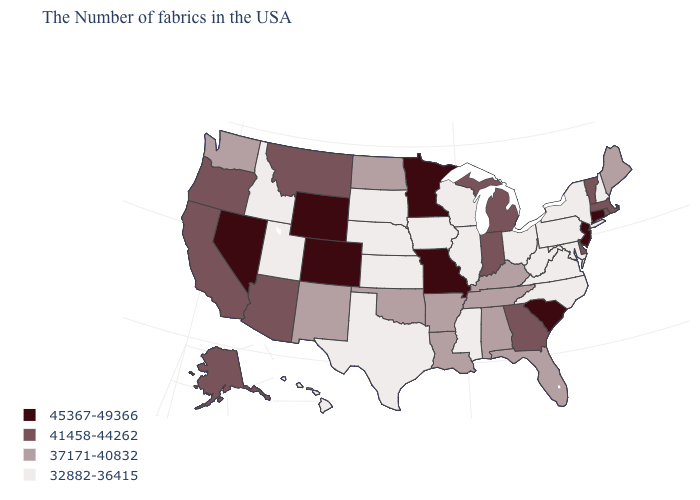Which states have the lowest value in the Northeast?
Write a very short answer. New Hampshire, New York, Pennsylvania. What is the value of Michigan?
Keep it brief. 41458-44262. Name the states that have a value in the range 37171-40832?
Be succinct. Maine, Florida, Kentucky, Alabama, Tennessee, Louisiana, Arkansas, Oklahoma, North Dakota, New Mexico, Washington. Which states hav the highest value in the MidWest?
Keep it brief. Missouri, Minnesota. Does the first symbol in the legend represent the smallest category?
Answer briefly. No. Among the states that border Georgia , does North Carolina have the lowest value?
Be succinct. Yes. Name the states that have a value in the range 37171-40832?
Keep it brief. Maine, Florida, Kentucky, Alabama, Tennessee, Louisiana, Arkansas, Oklahoma, North Dakota, New Mexico, Washington. Does Ohio have the highest value in the USA?
Give a very brief answer. No. What is the value of Vermont?
Keep it brief. 41458-44262. Name the states that have a value in the range 32882-36415?
Short answer required. New Hampshire, New York, Maryland, Pennsylvania, Virginia, North Carolina, West Virginia, Ohio, Wisconsin, Illinois, Mississippi, Iowa, Kansas, Nebraska, Texas, South Dakota, Utah, Idaho, Hawaii. Name the states that have a value in the range 37171-40832?
Write a very short answer. Maine, Florida, Kentucky, Alabama, Tennessee, Louisiana, Arkansas, Oklahoma, North Dakota, New Mexico, Washington. What is the value of New York?
Be succinct. 32882-36415. Does the first symbol in the legend represent the smallest category?
Concise answer only. No. What is the value of Texas?
Quick response, please. 32882-36415. Which states hav the highest value in the Northeast?
Quick response, please. Connecticut, New Jersey. 